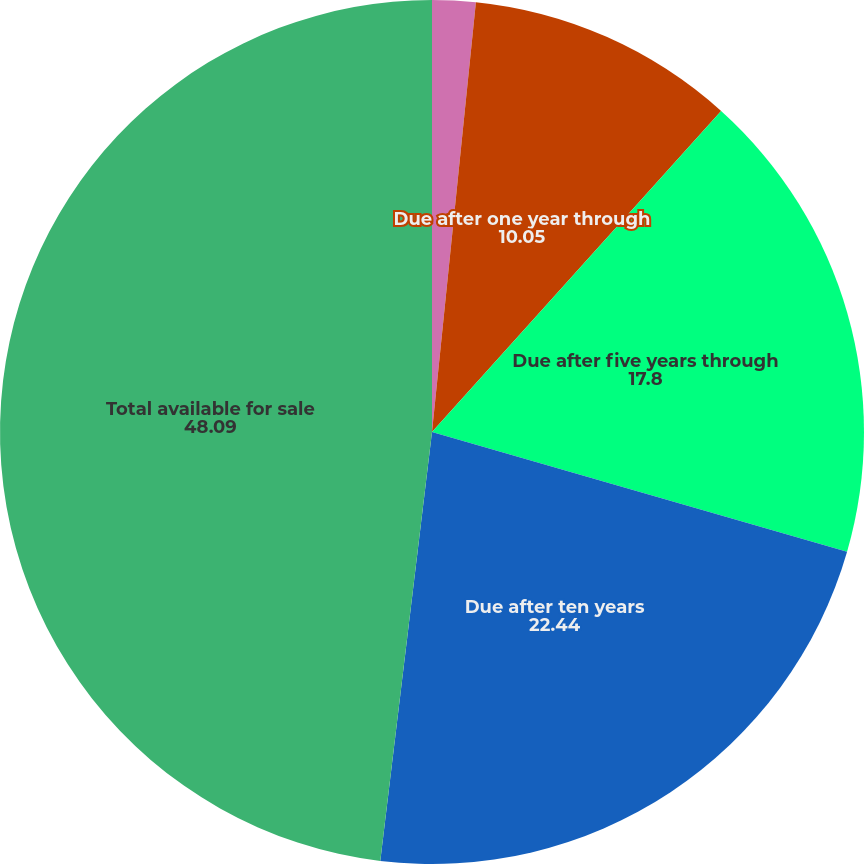Convert chart. <chart><loc_0><loc_0><loc_500><loc_500><pie_chart><fcel>Due in one year or less<fcel>Due after one year through<fcel>Due after five years through<fcel>Due after ten years<fcel>Total available for sale<nl><fcel>1.62%<fcel>10.05%<fcel>17.8%<fcel>22.44%<fcel>48.09%<nl></chart> 